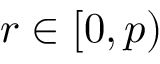<formula> <loc_0><loc_0><loc_500><loc_500>r \in [ 0 , p )</formula> 